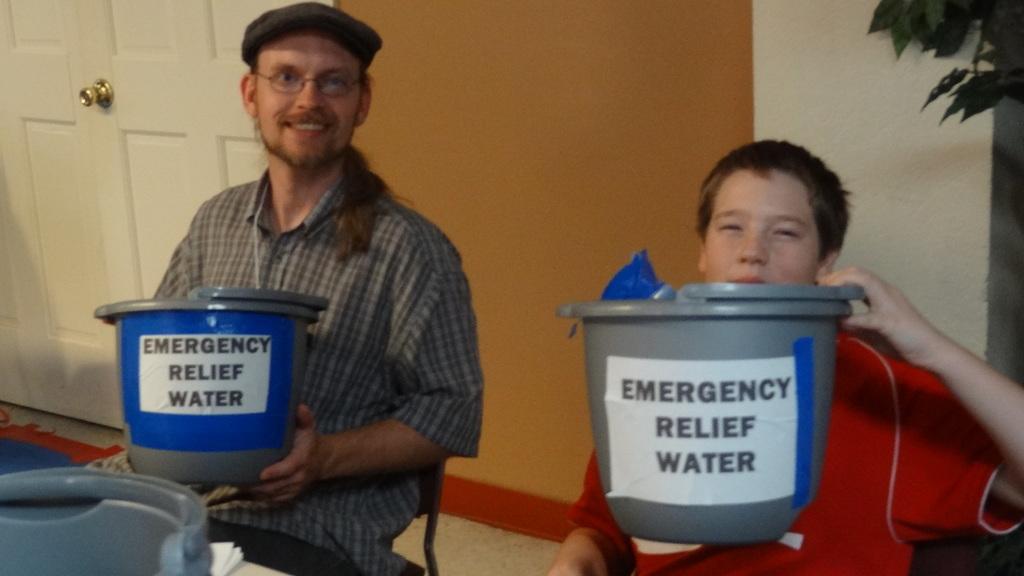What is in the buckets?
Your response must be concise. Emergency relief water. What does the gray bucket say?
Provide a succinct answer. Emergency relief water. 